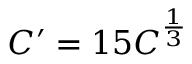<formula> <loc_0><loc_0><loc_500><loc_500>C ^ { \prime } = 1 5 C ^ { \frac { 1 } { 3 } }</formula> 